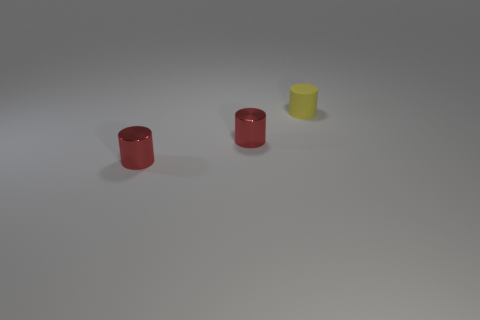Can you tell me what objects are present in the image and their colors? Certainly! There are three cylindrical objects in the image. Two of these objects are red with a shiny texture, and the third is yellow with a matte texture. 